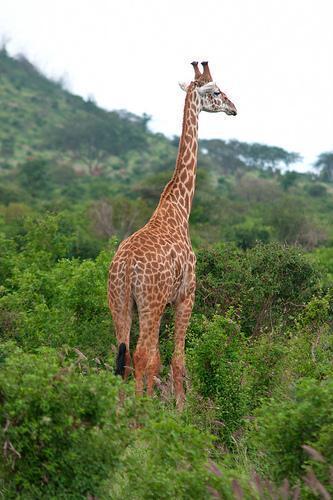How many giraffes are visible?
Give a very brief answer. 1. 